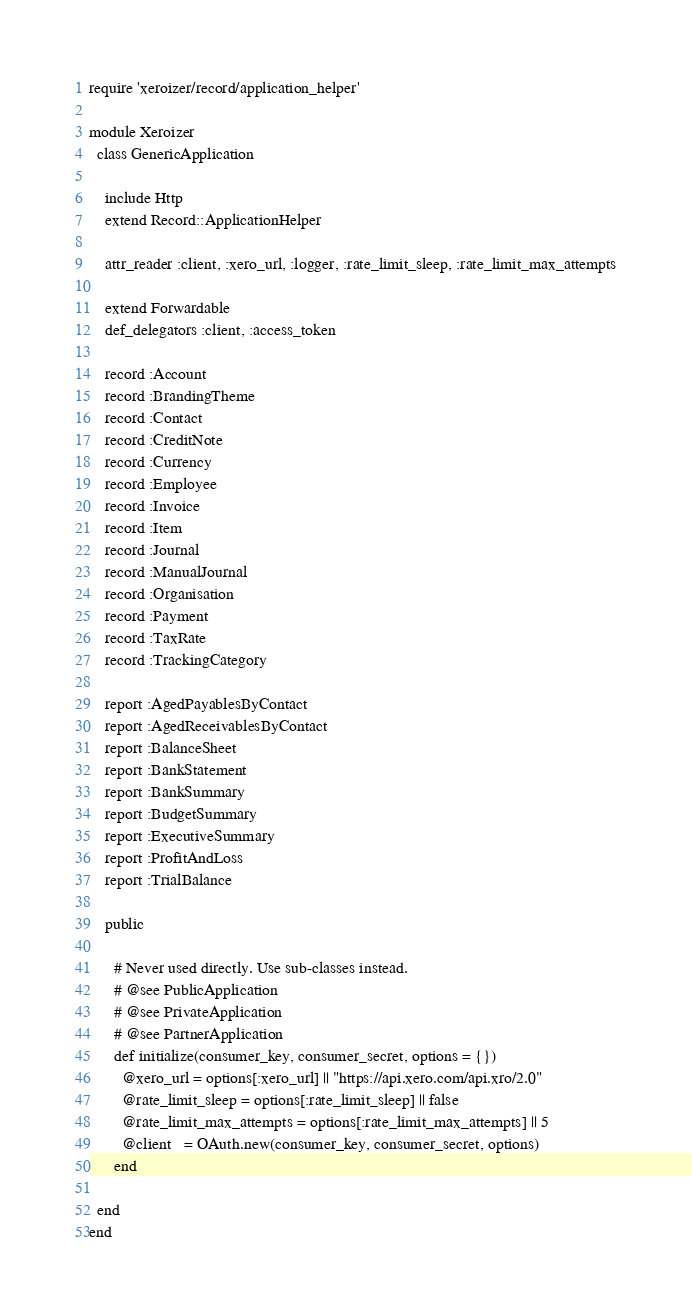Convert code to text. <code><loc_0><loc_0><loc_500><loc_500><_Ruby_>require 'xeroizer/record/application_helper'

module Xeroizer
  class GenericApplication
    
    include Http
    extend Record::ApplicationHelper
    
    attr_reader :client, :xero_url, :logger, :rate_limit_sleep, :rate_limit_max_attempts
    
    extend Forwardable
    def_delegators :client, :access_token
    
    record :Account
    record :BrandingTheme
    record :Contact
    record :CreditNote
    record :Currency
    record :Employee
    record :Invoice
    record :Item
    record :Journal
    record :ManualJournal
    record :Organisation
    record :Payment
    record :TaxRate
    record :TrackingCategory
    
    report :AgedPayablesByContact
    report :AgedReceivablesByContact
    report :BalanceSheet
    report :BankStatement
    report :BankSummary
    report :BudgetSummary
    report :ExecutiveSummary
    report :ProfitAndLoss
    report :TrialBalance
    
    public
    
      # Never used directly. Use sub-classes instead.
      # @see PublicApplication
      # @see PrivateApplication
      # @see PartnerApplication
      def initialize(consumer_key, consumer_secret, options = {})
        @xero_url = options[:xero_url] || "https://api.xero.com/api.xro/2.0"
        @rate_limit_sleep = options[:rate_limit_sleep] || false
        @rate_limit_max_attempts = options[:rate_limit_max_attempts] || 5
        @client   = OAuth.new(consumer_key, consumer_secret, options)
      end
          
  end
end
</code> 